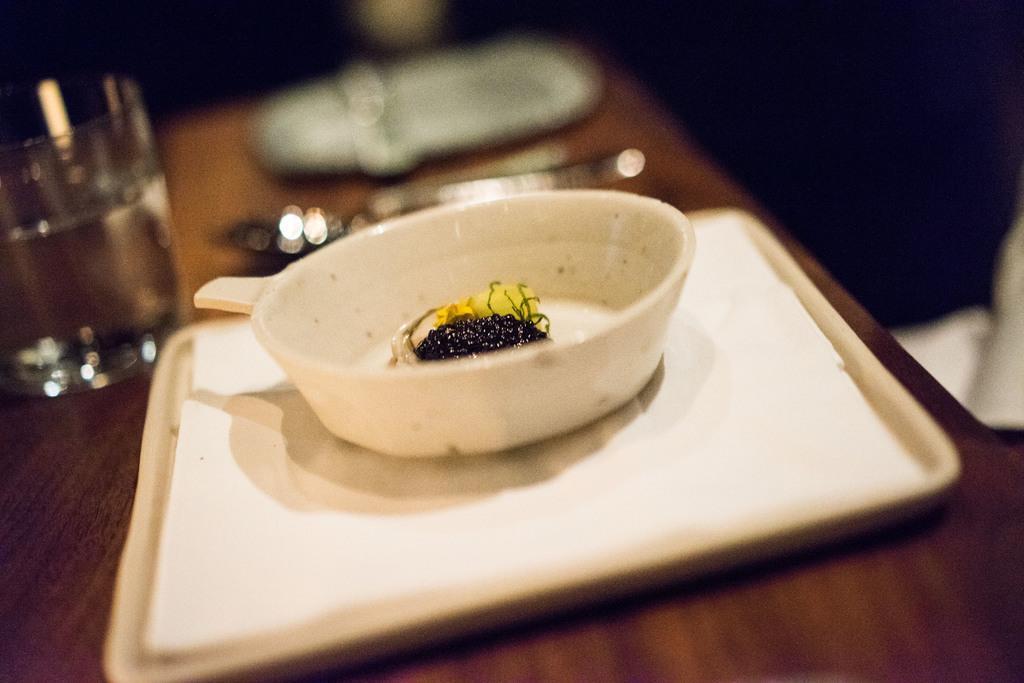How would you summarize this image in a sentence or two? In this image I can see the plate, glass and bowl on the brown color table. And I can see the blurred background. 